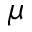Convert formula to latex. <formula><loc_0><loc_0><loc_500><loc_500>\mu</formula> 